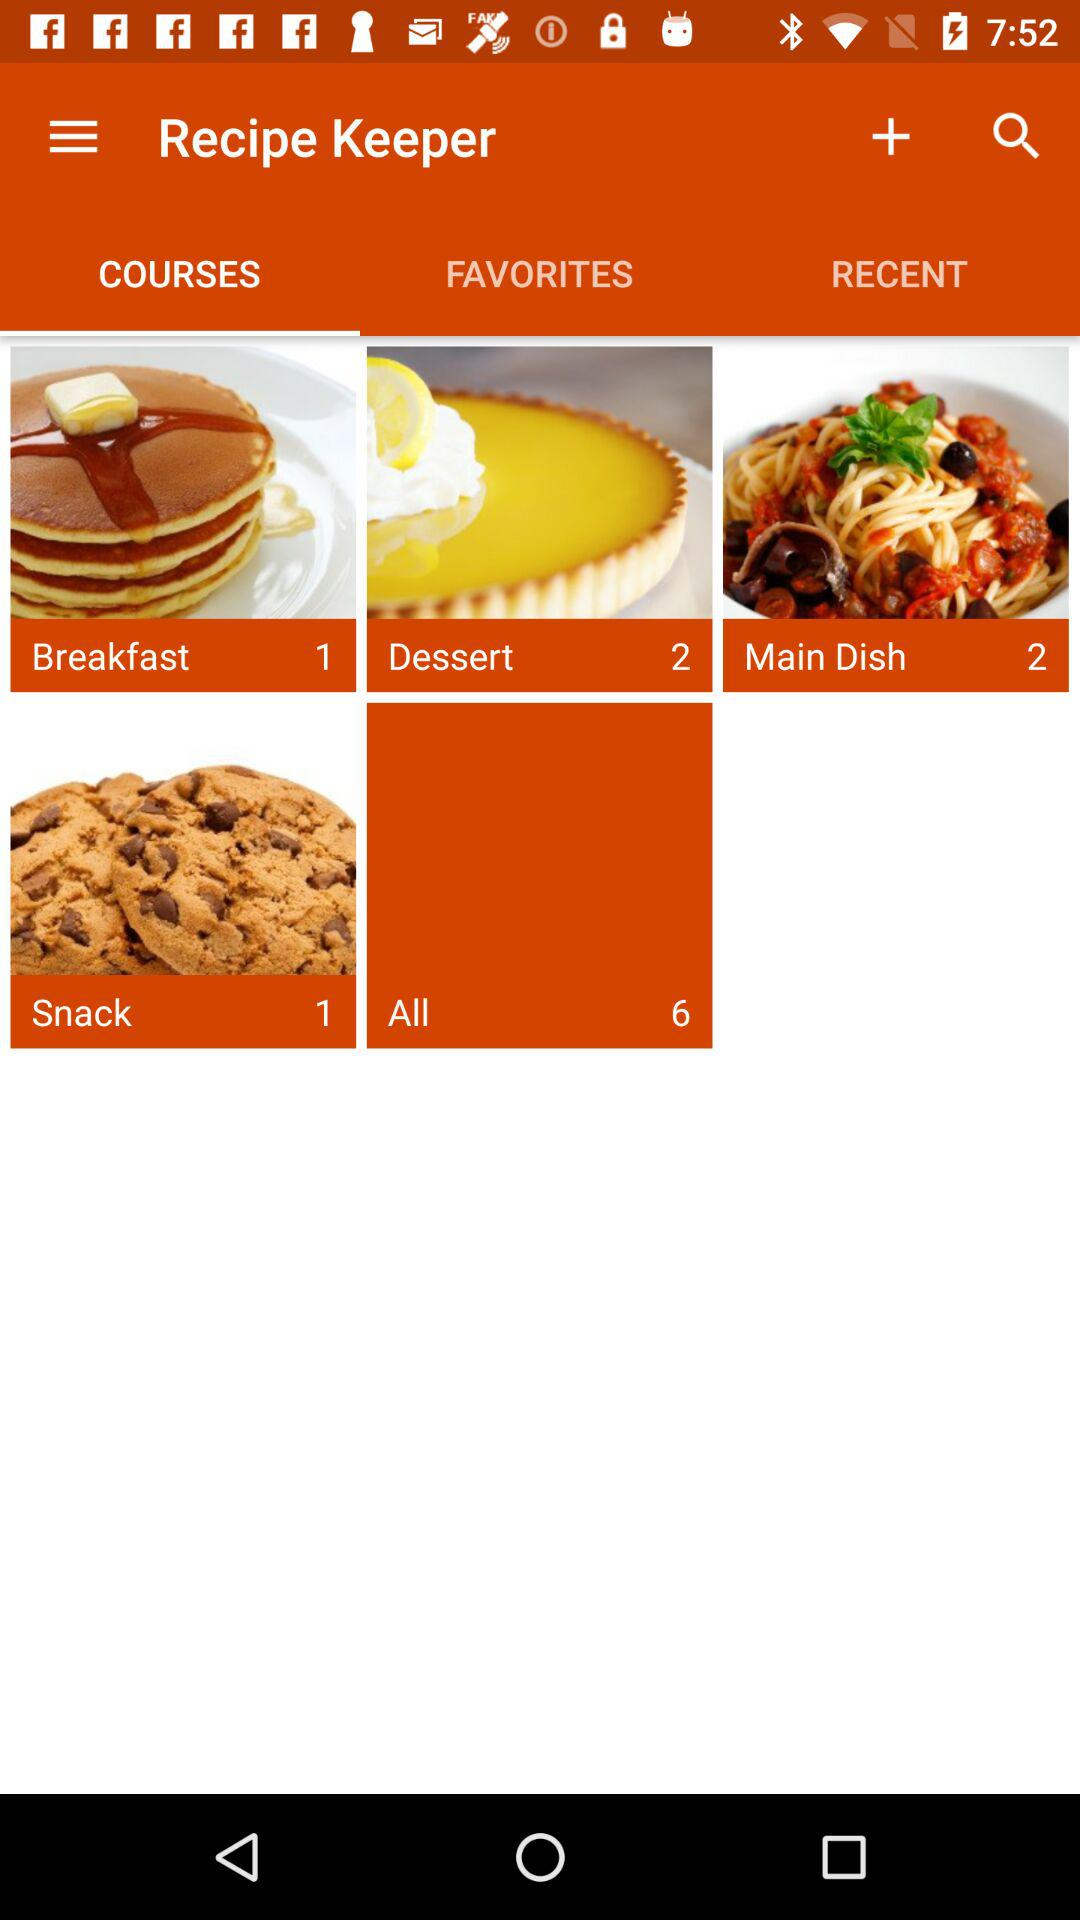How many recipes are in the All category?
Answer the question using a single word or phrase. 6 